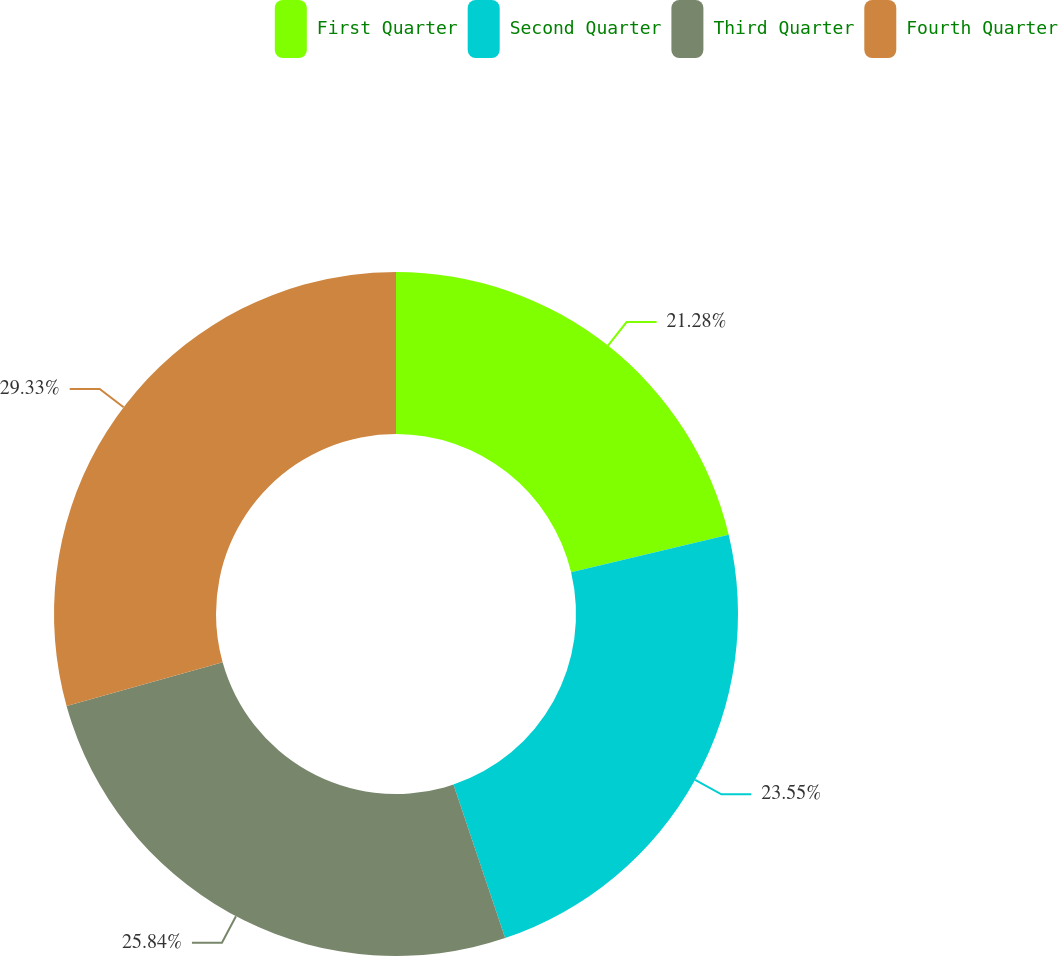Convert chart. <chart><loc_0><loc_0><loc_500><loc_500><pie_chart><fcel>First Quarter<fcel>Second Quarter<fcel>Third Quarter<fcel>Fourth Quarter<nl><fcel>21.28%<fcel>23.55%<fcel>25.84%<fcel>29.33%<nl></chart> 